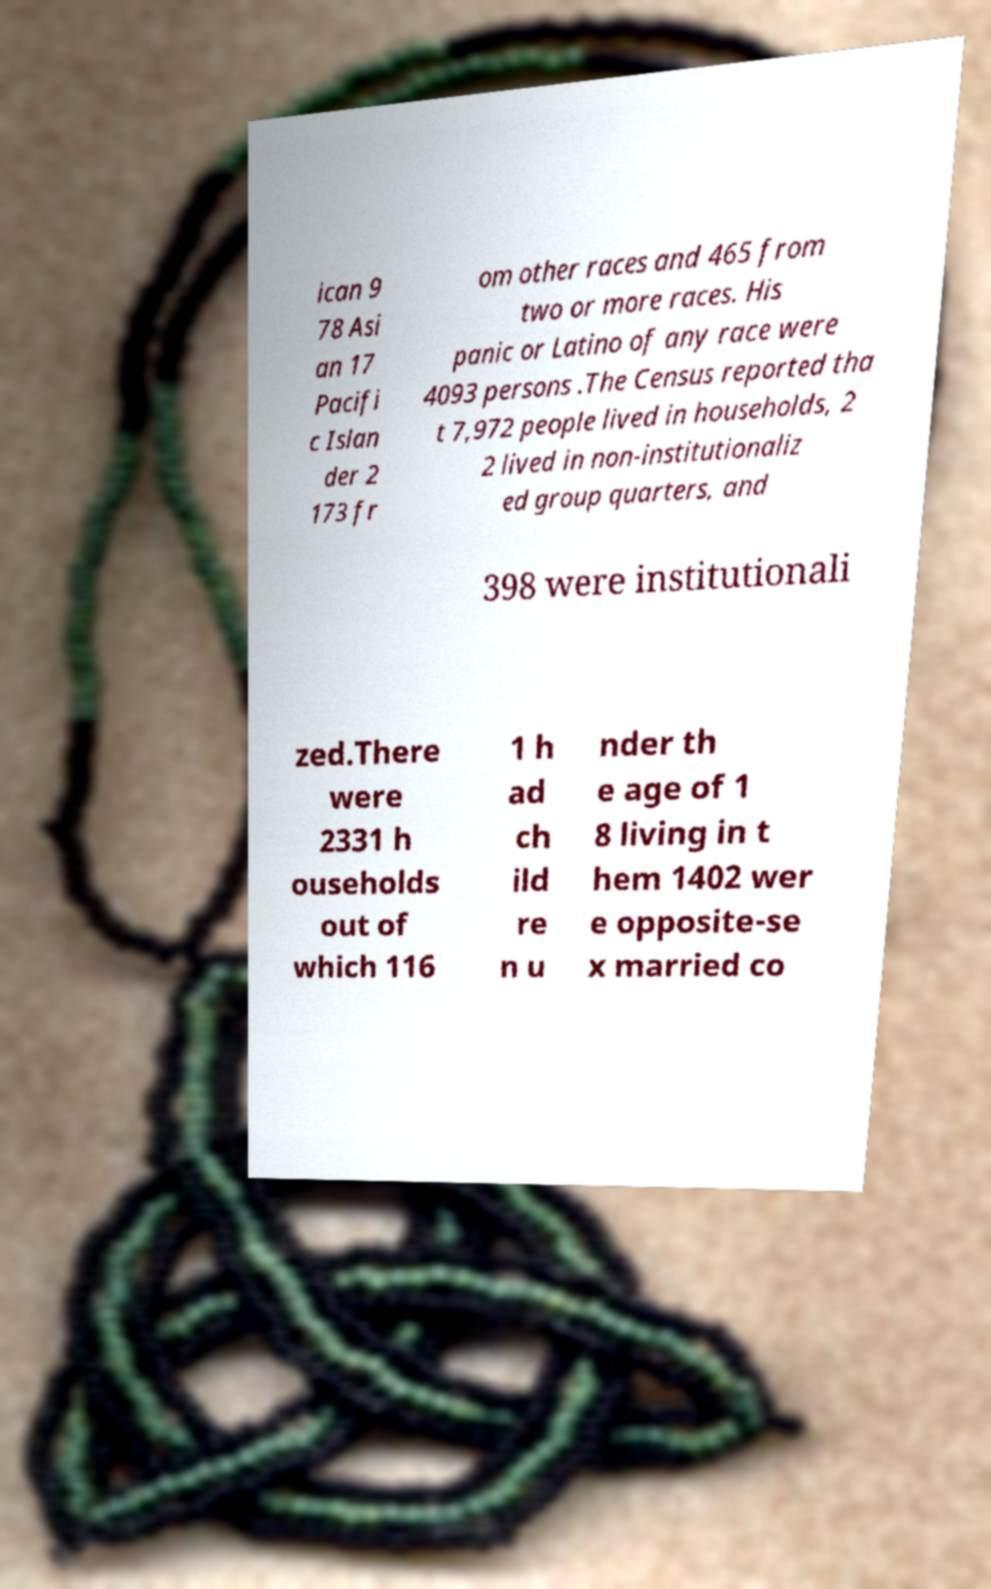There's text embedded in this image that I need extracted. Can you transcribe it verbatim? ican 9 78 Asi an 17 Pacifi c Islan der 2 173 fr om other races and 465 from two or more races. His panic or Latino of any race were 4093 persons .The Census reported tha t 7,972 people lived in households, 2 2 lived in non-institutionaliz ed group quarters, and 398 were institutionali zed.There were 2331 h ouseholds out of which 116 1 h ad ch ild re n u nder th e age of 1 8 living in t hem 1402 wer e opposite-se x married co 